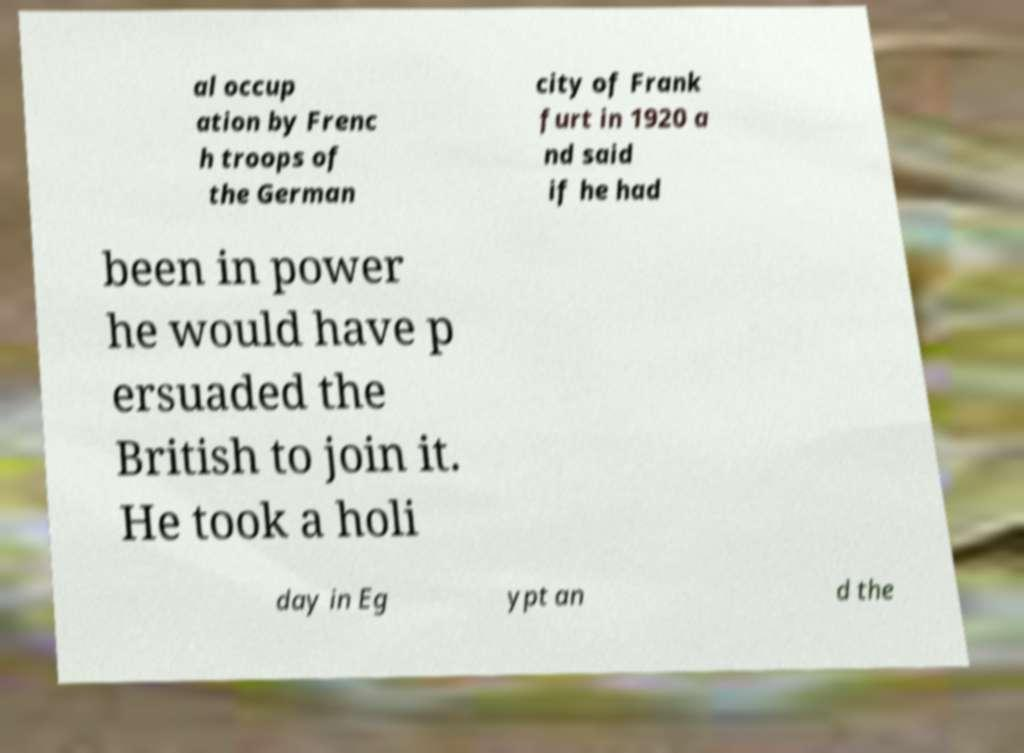Can you accurately transcribe the text from the provided image for me? al occup ation by Frenc h troops of the German city of Frank furt in 1920 a nd said if he had been in power he would have p ersuaded the British to join it. He took a holi day in Eg ypt an d the 